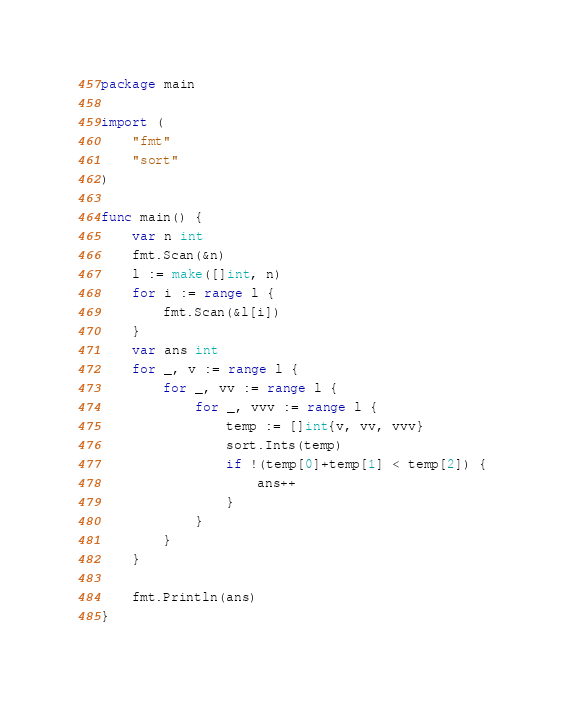<code> <loc_0><loc_0><loc_500><loc_500><_Go_>package main

import (
	"fmt"
	"sort"
)

func main() {
	var n int
	fmt.Scan(&n)
	l := make([]int, n)
	for i := range l {
		fmt.Scan(&l[i])
	}
	var ans int
	for _, v := range l {
		for _, vv := range l {
			for _, vvv := range l {
				temp := []int{v, vv, vvv}
				sort.Ints(temp)
				if !(temp[0]+temp[1] < temp[2]) {
					ans++
				}
			}
		}
	}

	fmt.Println(ans)
}
</code> 